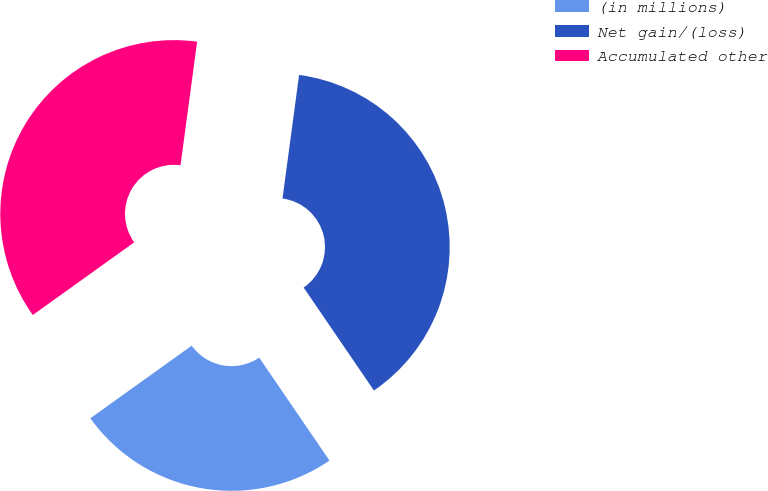<chart> <loc_0><loc_0><loc_500><loc_500><pie_chart><fcel>(in millions)<fcel>Net gain/(loss)<fcel>Accumulated other<nl><fcel>24.64%<fcel>38.34%<fcel>37.02%<nl></chart> 